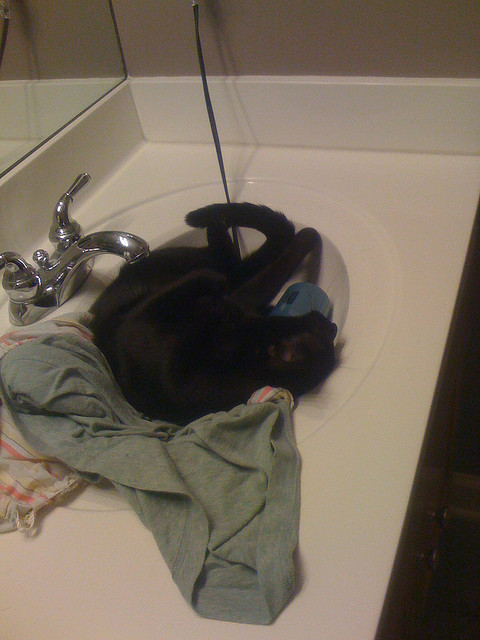Imagine the sink could talk. What would it say to the cat? "Hello there, Midnight! I see you've found my cozy basin again. You always bring warmth and excitement to my otherwise quiet existence. I enjoy your purring vibrations and the gentle kneading of your paws on the soft towels. Stay as long as you like, as you bring a delightful charm to this corner of the bathroom." 